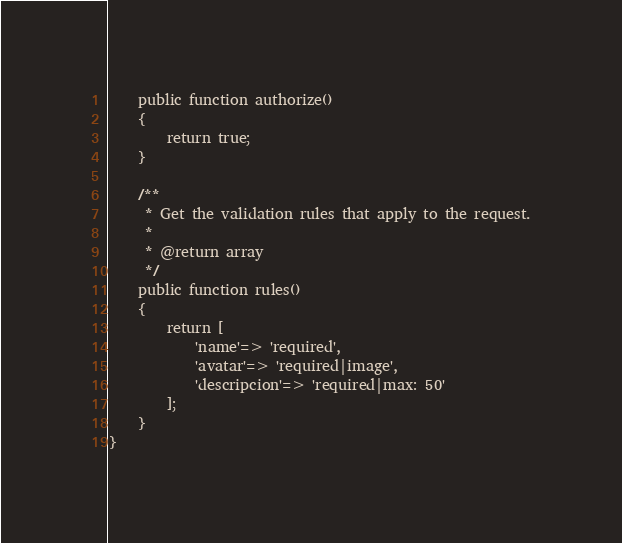Convert code to text. <code><loc_0><loc_0><loc_500><loc_500><_PHP_>    public function authorize()
    {
        return true;
    }

    /**
     * Get the validation rules that apply to the request.
     *
     * @return array
     */
    public function rules()
    {
        return [
            'name'=> 'required',
            'avatar'=> 'required|image',
            'descripcion'=> 'required|max: 50'
        ];
    }
}
</code> 